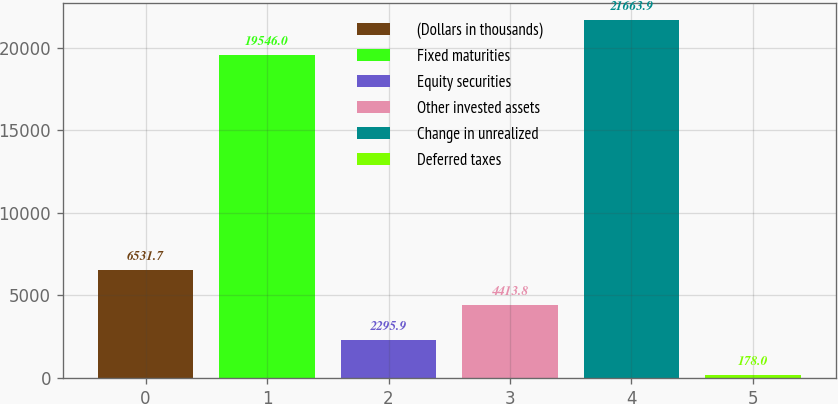Convert chart to OTSL. <chart><loc_0><loc_0><loc_500><loc_500><bar_chart><fcel>(Dollars in thousands)<fcel>Fixed maturities<fcel>Equity securities<fcel>Other invested assets<fcel>Change in unrealized<fcel>Deferred taxes<nl><fcel>6531.7<fcel>19546<fcel>2295.9<fcel>4413.8<fcel>21663.9<fcel>178<nl></chart> 